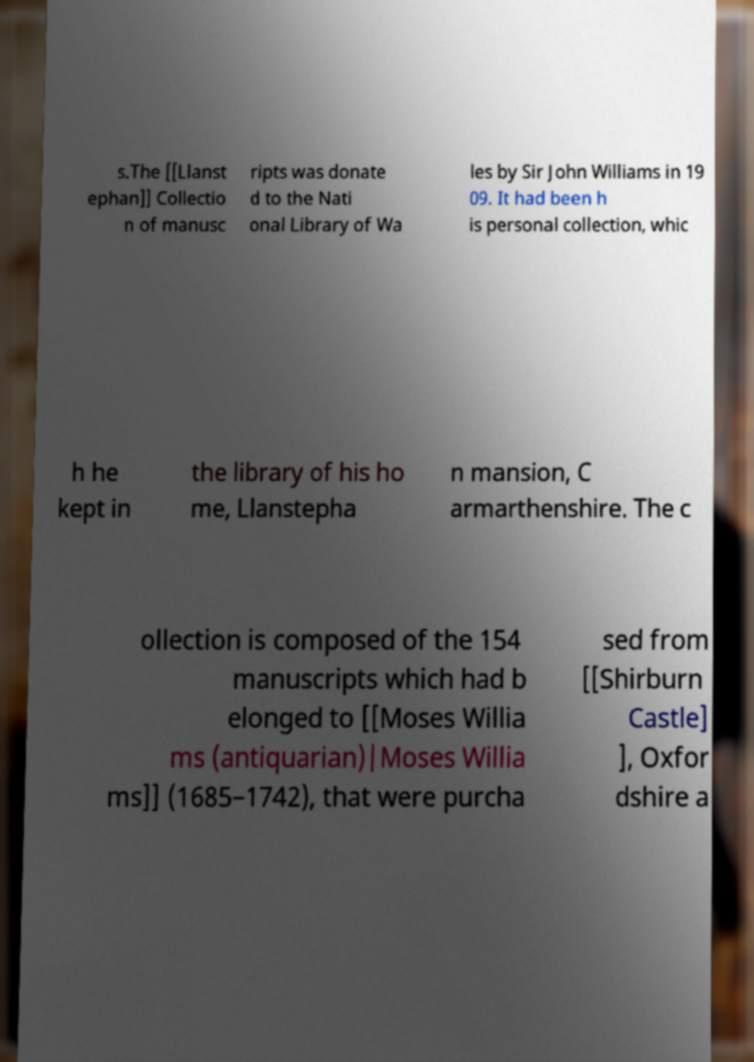Can you accurately transcribe the text from the provided image for me? s.The [[Llanst ephan]] Collectio n of manusc ripts was donate d to the Nati onal Library of Wa les by Sir John Williams in 19 09. It had been h is personal collection, whic h he kept in the library of his ho me, Llanstepha n mansion, C armarthenshire. The c ollection is composed of the 154 manuscripts which had b elonged to [[Moses Willia ms (antiquarian)|Moses Willia ms]] (1685–1742), that were purcha sed from [[Shirburn Castle] ], Oxfor dshire a 